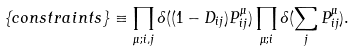Convert formula to latex. <formula><loc_0><loc_0><loc_500><loc_500>\{ c o n s t r a i n t s \} \equiv \prod _ { \mu ; i , j } \delta ( ( 1 - D _ { i j } ) P ^ { \mu } _ { i j } ) \prod _ { \mu ; i } \delta ( \sum _ { j } P _ { i j } ^ { \mu } ) .</formula> 